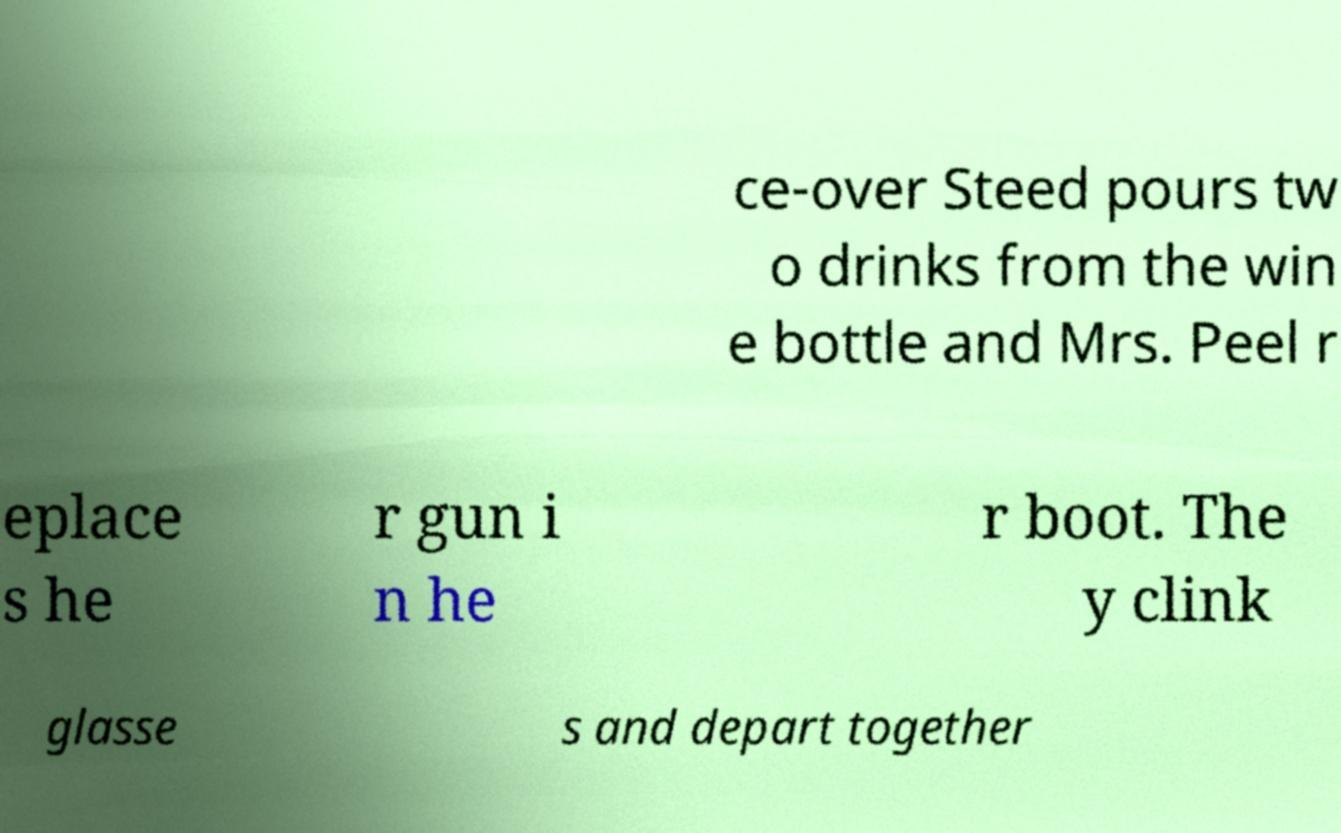Could you extract and type out the text from this image? ce-over Steed pours tw o drinks from the win e bottle and Mrs. Peel r eplace s he r gun i n he r boot. The y clink glasse s and depart together 